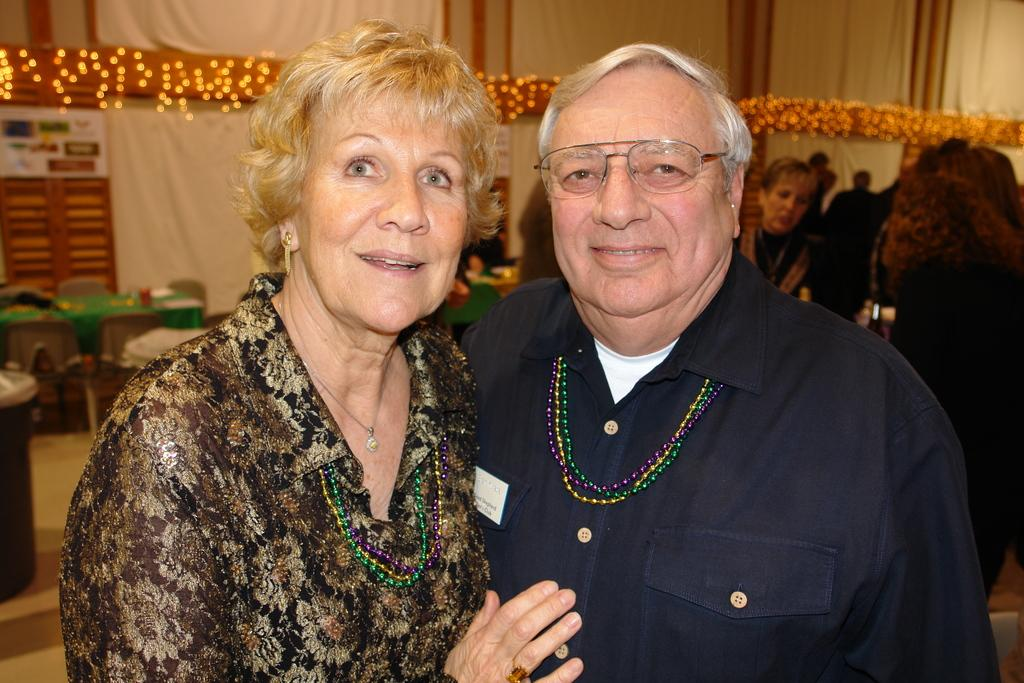Who can be seen in the image? There is a man and a woman in the image. Where are the man and woman located in the image? The man and woman are in the center of the image. What else can be seen in the background of the image? There are other people, a table, a poster, and lights in the background of the image. What type of toy is the man playing with in the image? There is no toy present in the image; the man and woman are simply standing in the center. 